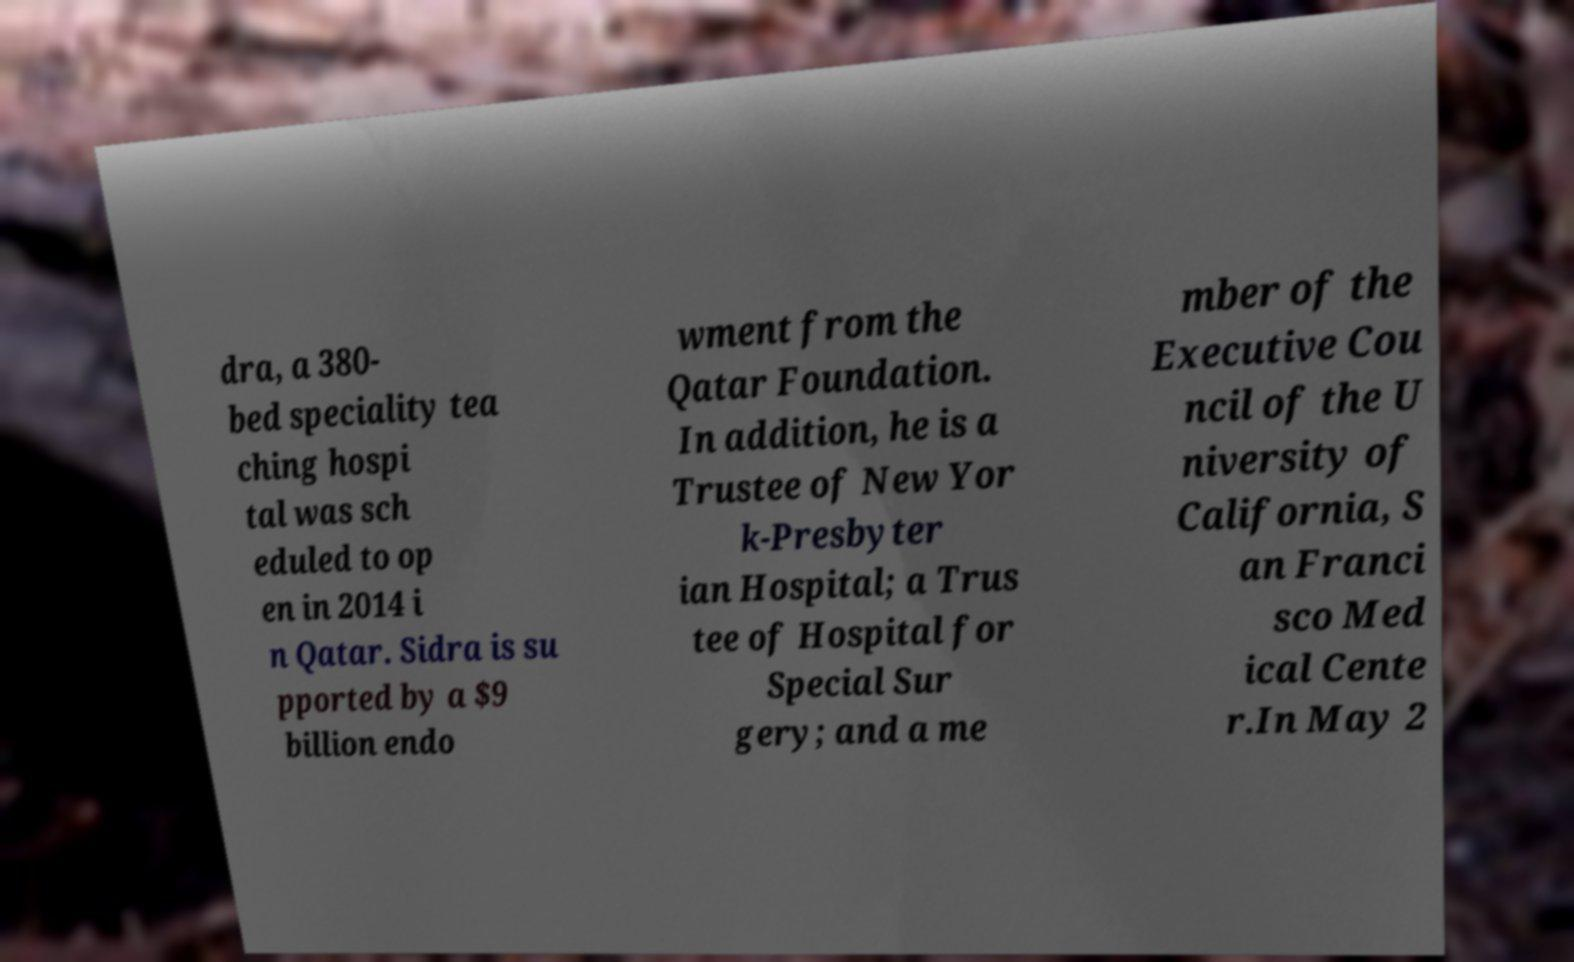Can you accurately transcribe the text from the provided image for me? dra, a 380- bed speciality tea ching hospi tal was sch eduled to op en in 2014 i n Qatar. Sidra is su pported by a $9 billion endo wment from the Qatar Foundation. In addition, he is a Trustee of New Yor k-Presbyter ian Hospital; a Trus tee of Hospital for Special Sur gery; and a me mber of the Executive Cou ncil of the U niversity of California, S an Franci sco Med ical Cente r.In May 2 